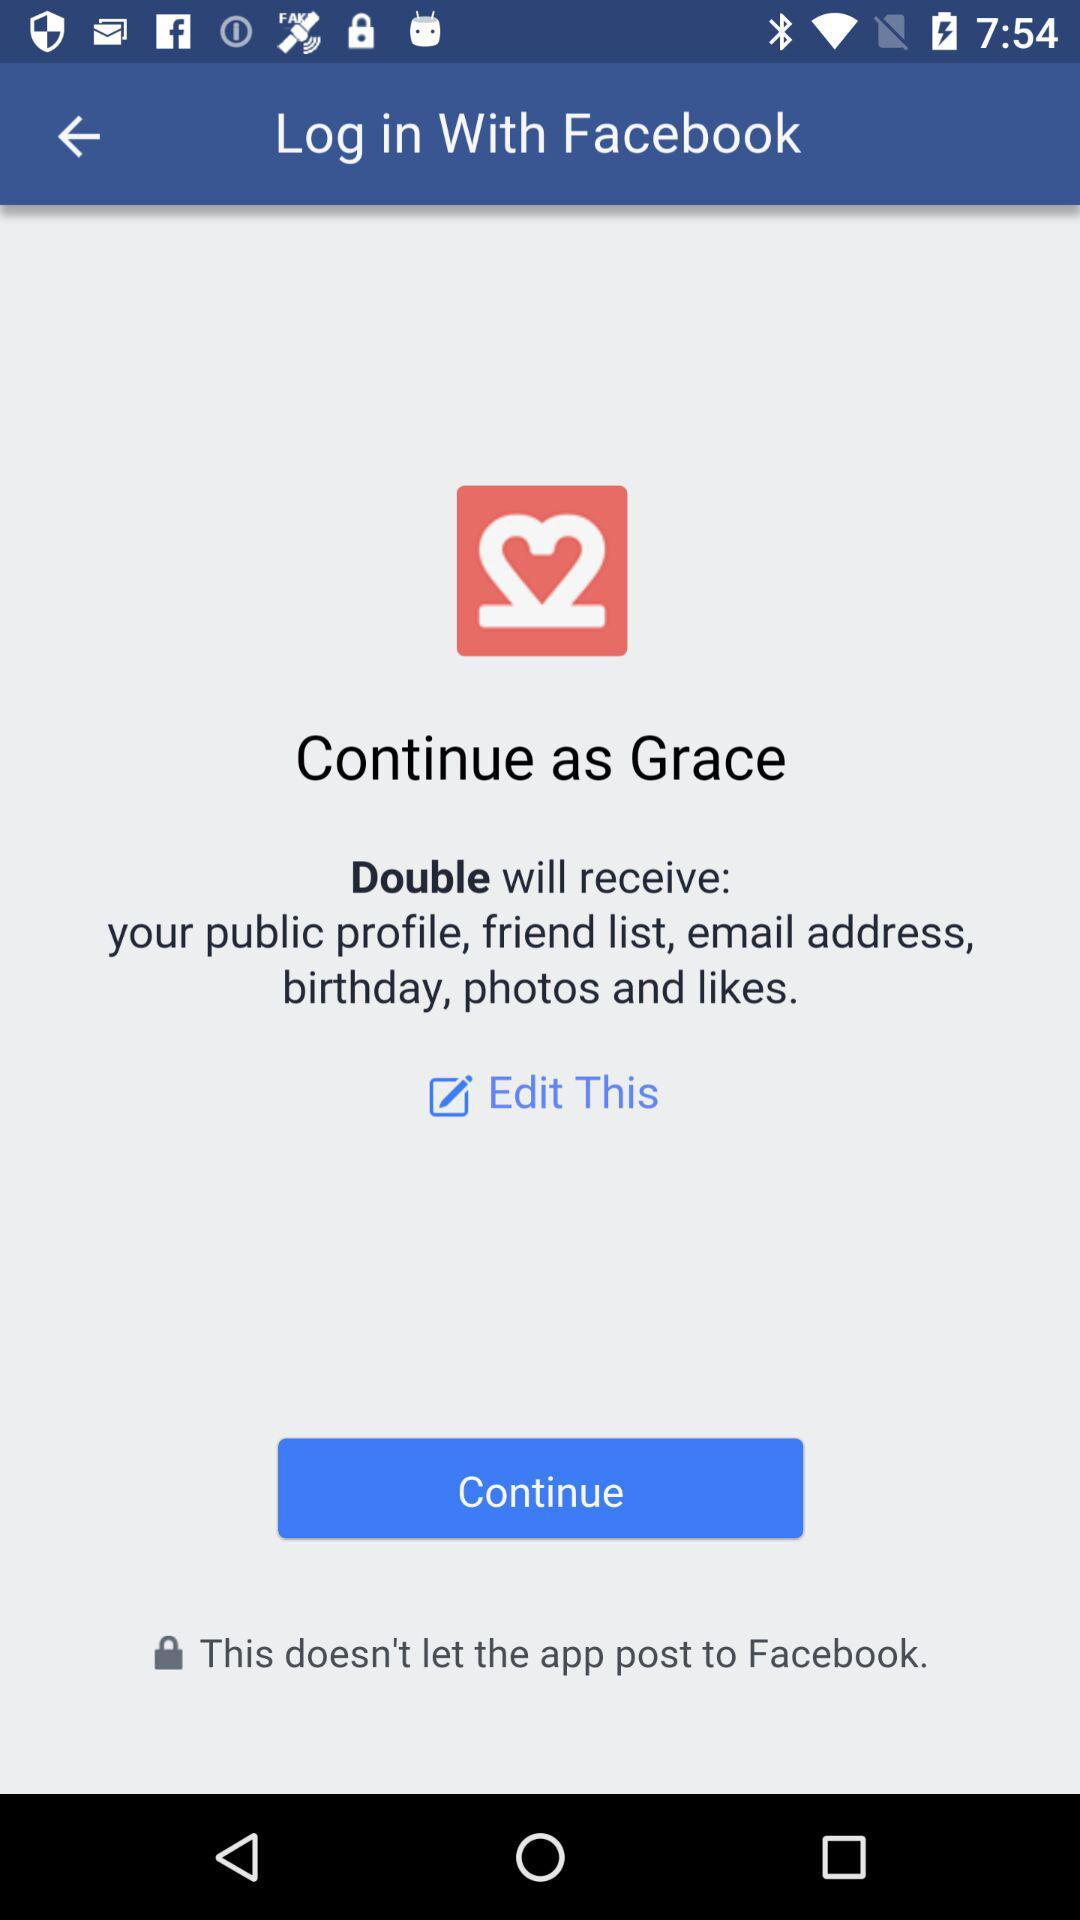How old is "Grace"?
When the provided information is insufficient, respond with <no answer>. <no answer> 